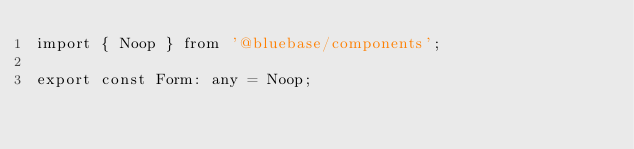Convert code to text. <code><loc_0><loc_0><loc_500><loc_500><_TypeScript_>import { Noop } from '@bluebase/components';

export const Form: any = Noop;
</code> 